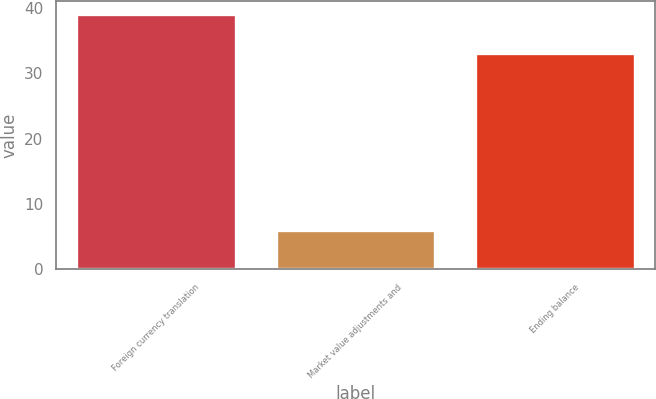<chart> <loc_0><loc_0><loc_500><loc_500><bar_chart><fcel>Foreign currency translation<fcel>Market value adjustments and<fcel>Ending balance<nl><fcel>39<fcel>6<fcel>33<nl></chart> 